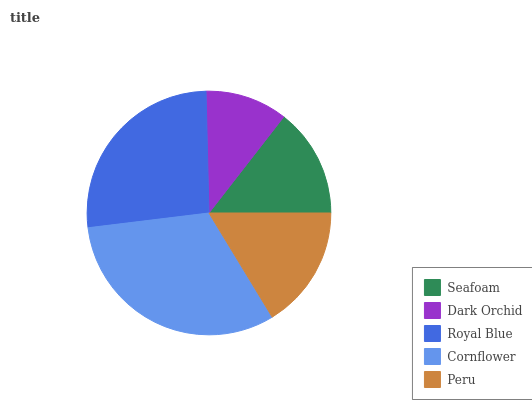Is Dark Orchid the minimum?
Answer yes or no. Yes. Is Cornflower the maximum?
Answer yes or no. Yes. Is Royal Blue the minimum?
Answer yes or no. No. Is Royal Blue the maximum?
Answer yes or no. No. Is Royal Blue greater than Dark Orchid?
Answer yes or no. Yes. Is Dark Orchid less than Royal Blue?
Answer yes or no. Yes. Is Dark Orchid greater than Royal Blue?
Answer yes or no. No. Is Royal Blue less than Dark Orchid?
Answer yes or no. No. Is Peru the high median?
Answer yes or no. Yes. Is Peru the low median?
Answer yes or no. Yes. Is Dark Orchid the high median?
Answer yes or no. No. Is Seafoam the low median?
Answer yes or no. No. 